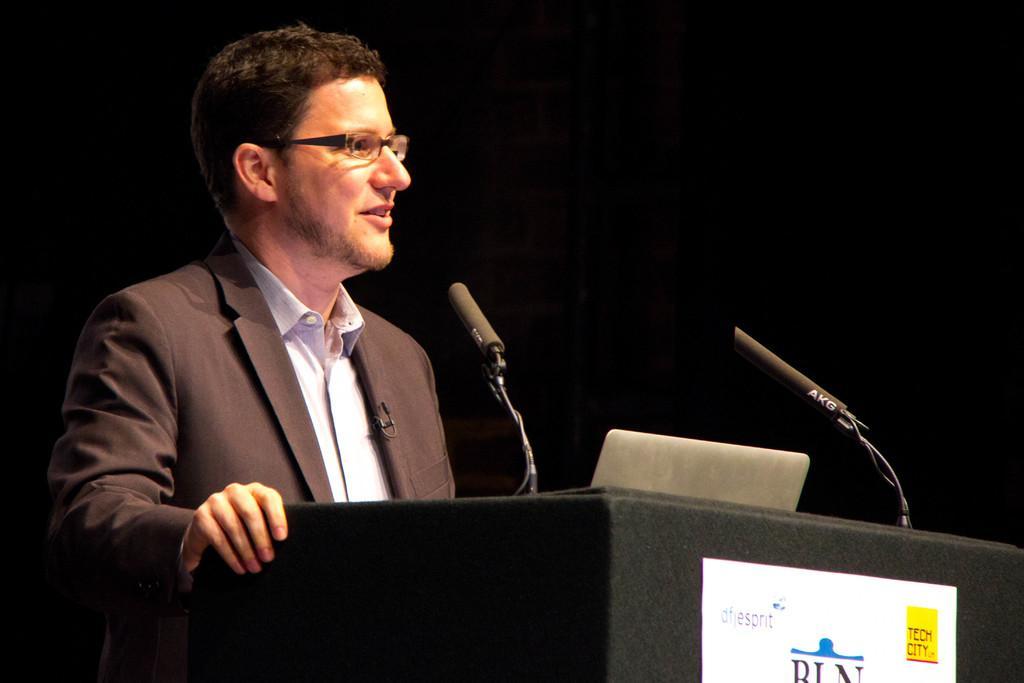Could you give a brief overview of what you see in this image? This image consists of a man wearing suit. He is standing in front of the podium and talking in a mic. There is a paper pasted on the podium. The background is too dark. 